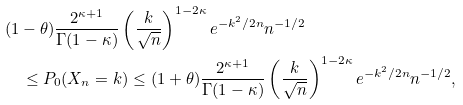<formula> <loc_0><loc_0><loc_500><loc_500>& ( 1 - \theta ) \frac { 2 ^ { \kappa + 1 } } { \Gamma ( 1 - \kappa ) } \left ( \frac { k } { \sqrt { n } } \right ) ^ { 1 - 2 \kappa } e ^ { - k ^ { 2 } / 2 n } n ^ { - 1 / 2 } \\ & \quad \leq P _ { 0 } ( X _ { n } = k ) \leq ( 1 + \theta ) \frac { 2 ^ { \kappa + 1 } } { \Gamma ( 1 - \kappa ) } \left ( \frac { k } { \sqrt { n } } \right ) ^ { 1 - 2 \kappa } e ^ { - k ^ { 2 } / 2 n } n ^ { - 1 / 2 } ,</formula> 